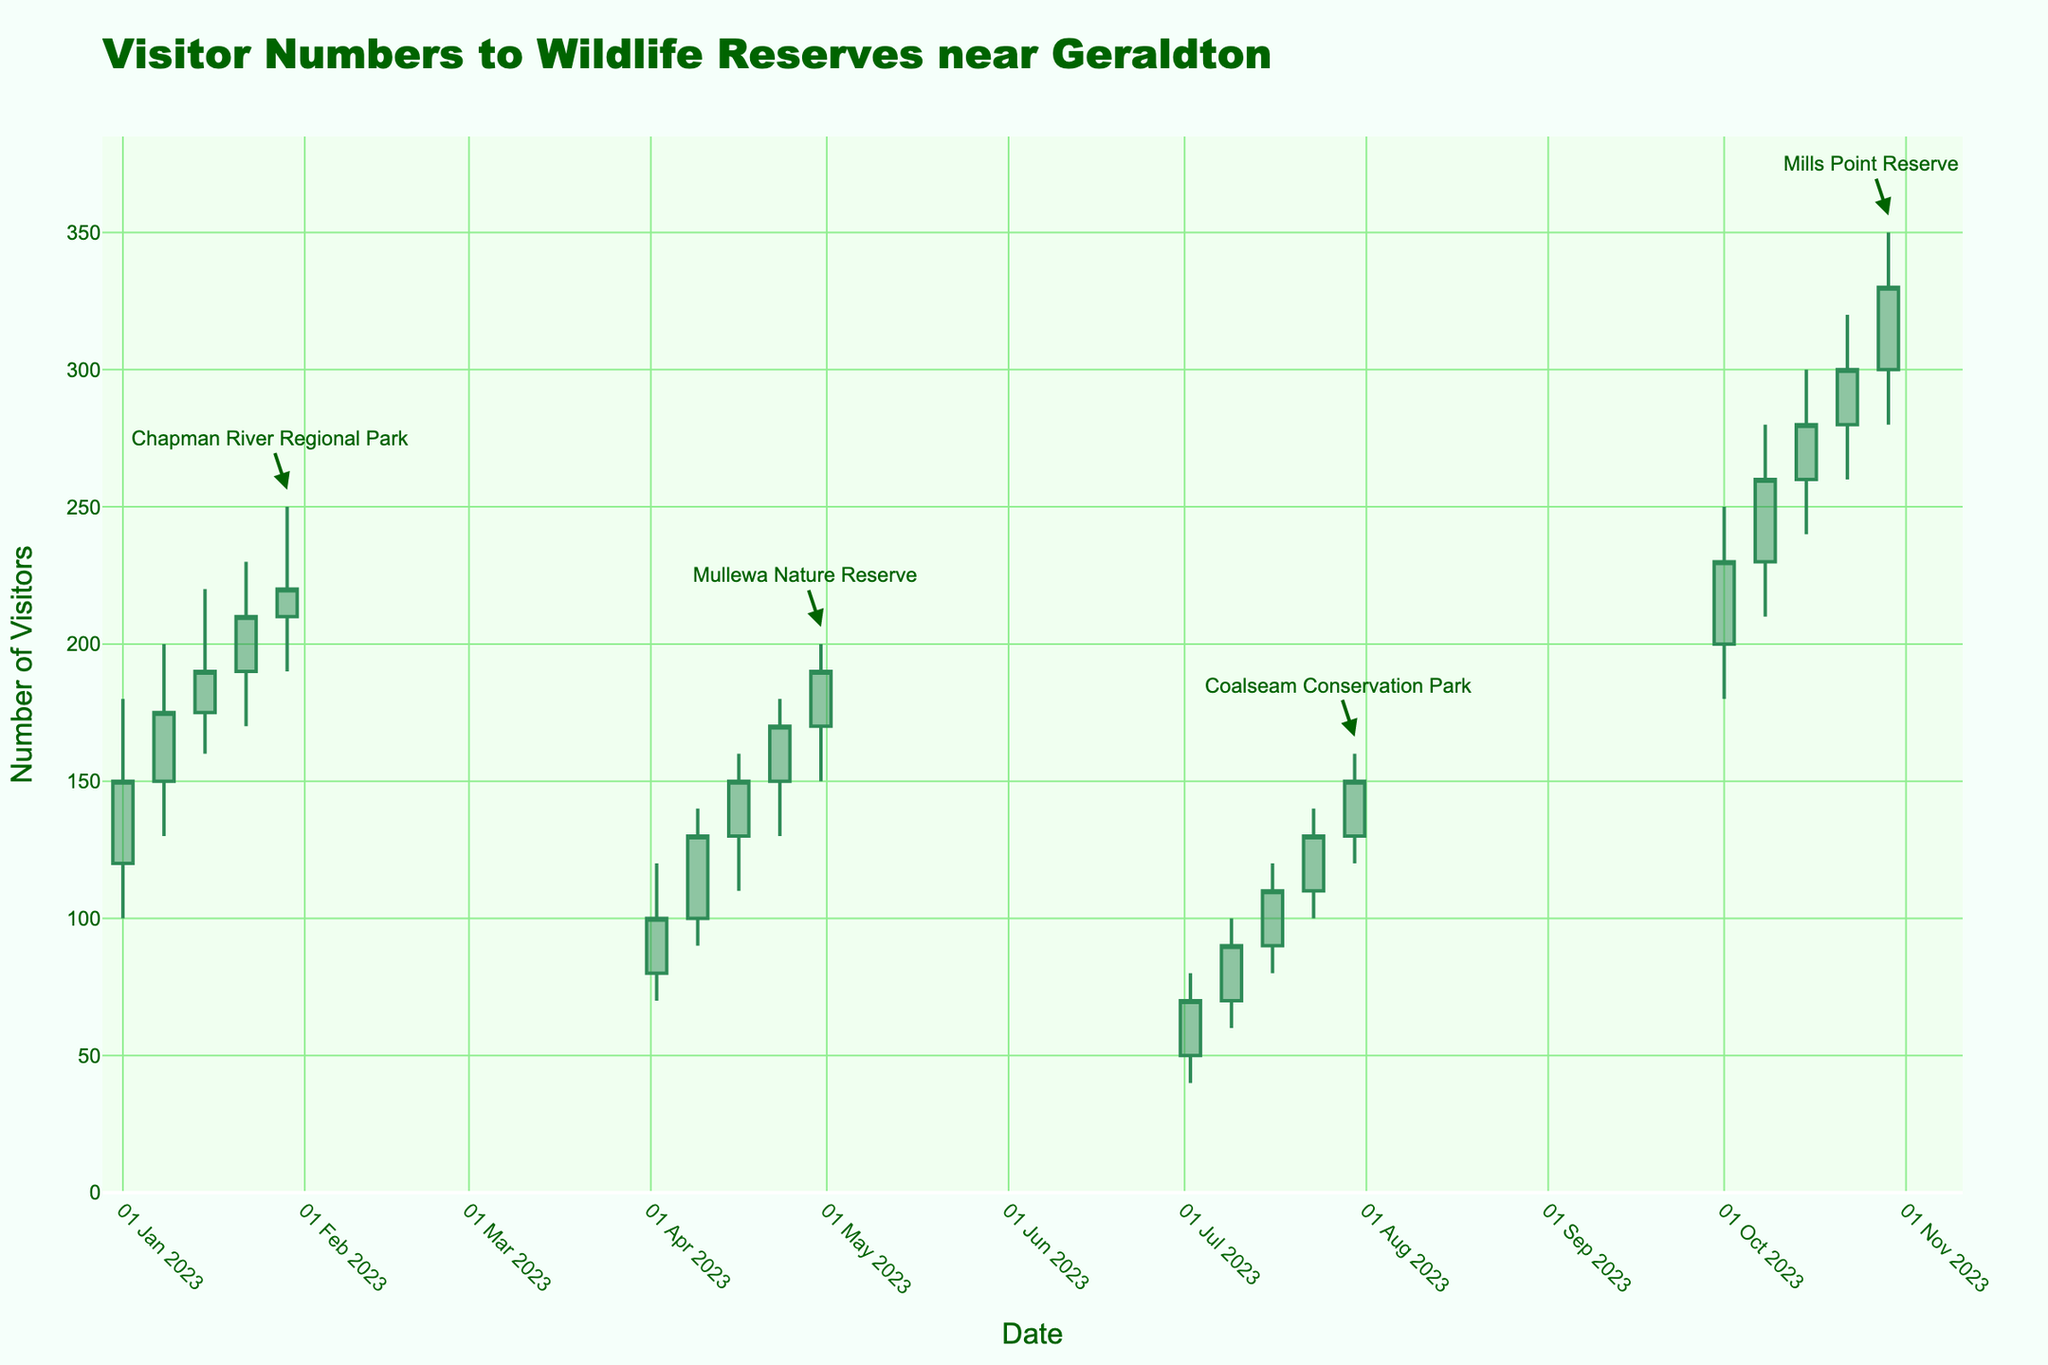what is the title of the chart? The chart's title is displayed at the top and reads "Visitor Numbers to Wildlife Reserves near Geraldton".
Answer: Visitor Numbers to Wildlife Reserves near Geraldton What are the colors of the increasing and decreasing lines in the OHLC chart? The colors of the lines for increasing and decreasing data points are described visually: increasing lines are colored Sea Green, and decreasing lines are colored Saddle Brown.
Answer: Sea Green (increasing) and Saddle Brown (decreasing) How many visitor data points are recorded for Chapman River Regional Park? The data points for this reserve span across the weeks of January. Counting each week, we observe a total of five data points.
Answer: 5 Which reserve had the highest visitor count in the entire dataset, and what was the count? Observing the highest peaks across all reserves, Mills Point Reserve had the peak in the week of October 29 with a high of 350 visitors.
Answer: Mills Point Reserve, 350 During which week in July did Coalseam Conservation Park have a visitor count closing at 130? By examining the closing values in July for Coalseam Conservation Park, the week of July 23 shows a closing count of 130 visitors.
Answer: Week of July 23 What is the range of visitor counts observed in Mullewa Nature Reserve during April? The data for Mullewa in April shows a minimum (low) of 70 and a maximum (high) of 200 visitors. Subtracting the low from the high gives a range of 200 - 70 = 130 visitors.
Answer: 130 Compare the visitor numbers on January 1 and January 29 for Chapman River Regional Park. Which day had higher closing and by how much? Comparing the closing numbers, on January 1, the figure is 150, and on January 29, the figure is 220. The difference is 220 - 150 = 70 visitors.
Answer: January 29, by 70 visitors How does the trend in visitor numbers change across weeks for Mills Point Reserve in October? Observing Mills Point Reserve in October, visitor numbers generally increase week over week. Starting from a close of 230 and reaching up to 330 by the end of the month.
Answer: Increasing trend What was the lowest number of visitors recorded in any given week for Coalseam Conservation Park? Looking at the low values for Coalseam Conservation Park in July, the lowest visitor count is 40, observed in the first week.
Answer: 40 Which reserve had the highest variance in visitor counts within a single month, and what was the variance? Calculating the ranges for each reserve within their respective months, Chapman River Regional Park in January (250-100=150), Mullewa in April (200-70=130), Coalseam in July (160-40=120), Mills Point in October (350-180=170). Mills Point Reserve stands out with the highest variance of 170.
Answer: Mills Point Reserve, 170 